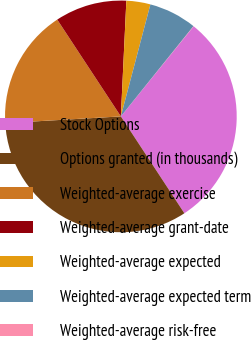<chart> <loc_0><loc_0><loc_500><loc_500><pie_chart><fcel>Stock Options<fcel>Options granted (in thousands)<fcel>Weighted-average exercise<fcel>Weighted-average grant-date<fcel>Weighted-average expected<fcel>Weighted-average expected term<fcel>Weighted-average risk-free<nl><fcel>29.95%<fcel>33.31%<fcel>16.67%<fcel>10.01%<fcel>3.35%<fcel>6.68%<fcel>0.03%<nl></chart> 